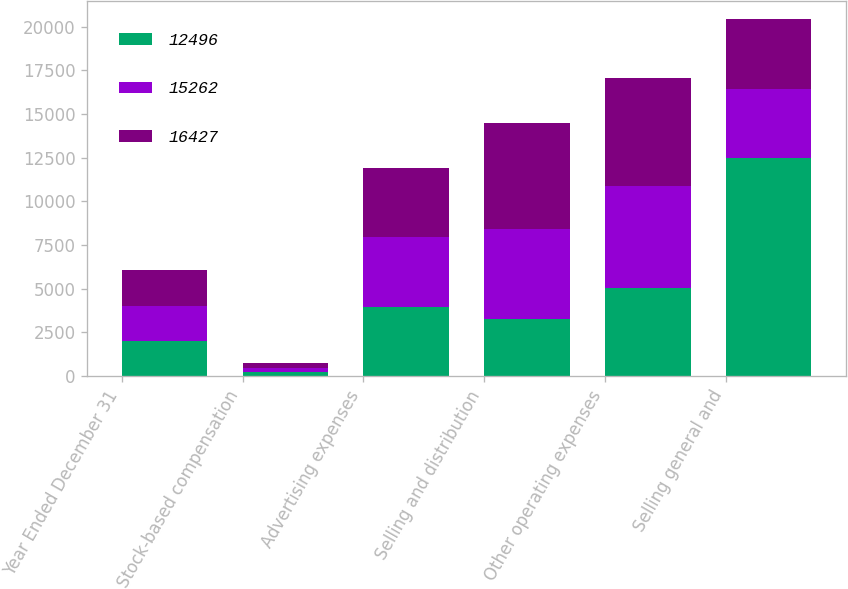Convert chart. <chart><loc_0><loc_0><loc_500><loc_500><stacked_bar_chart><ecel><fcel>Year Ended December 31<fcel>Stock-based compensation<fcel>Advertising expenses<fcel>Selling and distribution<fcel>Other operating expenses<fcel>Selling general and<nl><fcel>12496<fcel>2017<fcel>219<fcel>3958<fcel>3257<fcel>5062<fcel>12496<nl><fcel>15262<fcel>2016<fcel>258<fcel>4004<fcel>5177<fcel>5823<fcel>3967<nl><fcel>16427<fcel>2015<fcel>236<fcel>3976<fcel>6025<fcel>6190<fcel>3967<nl></chart> 